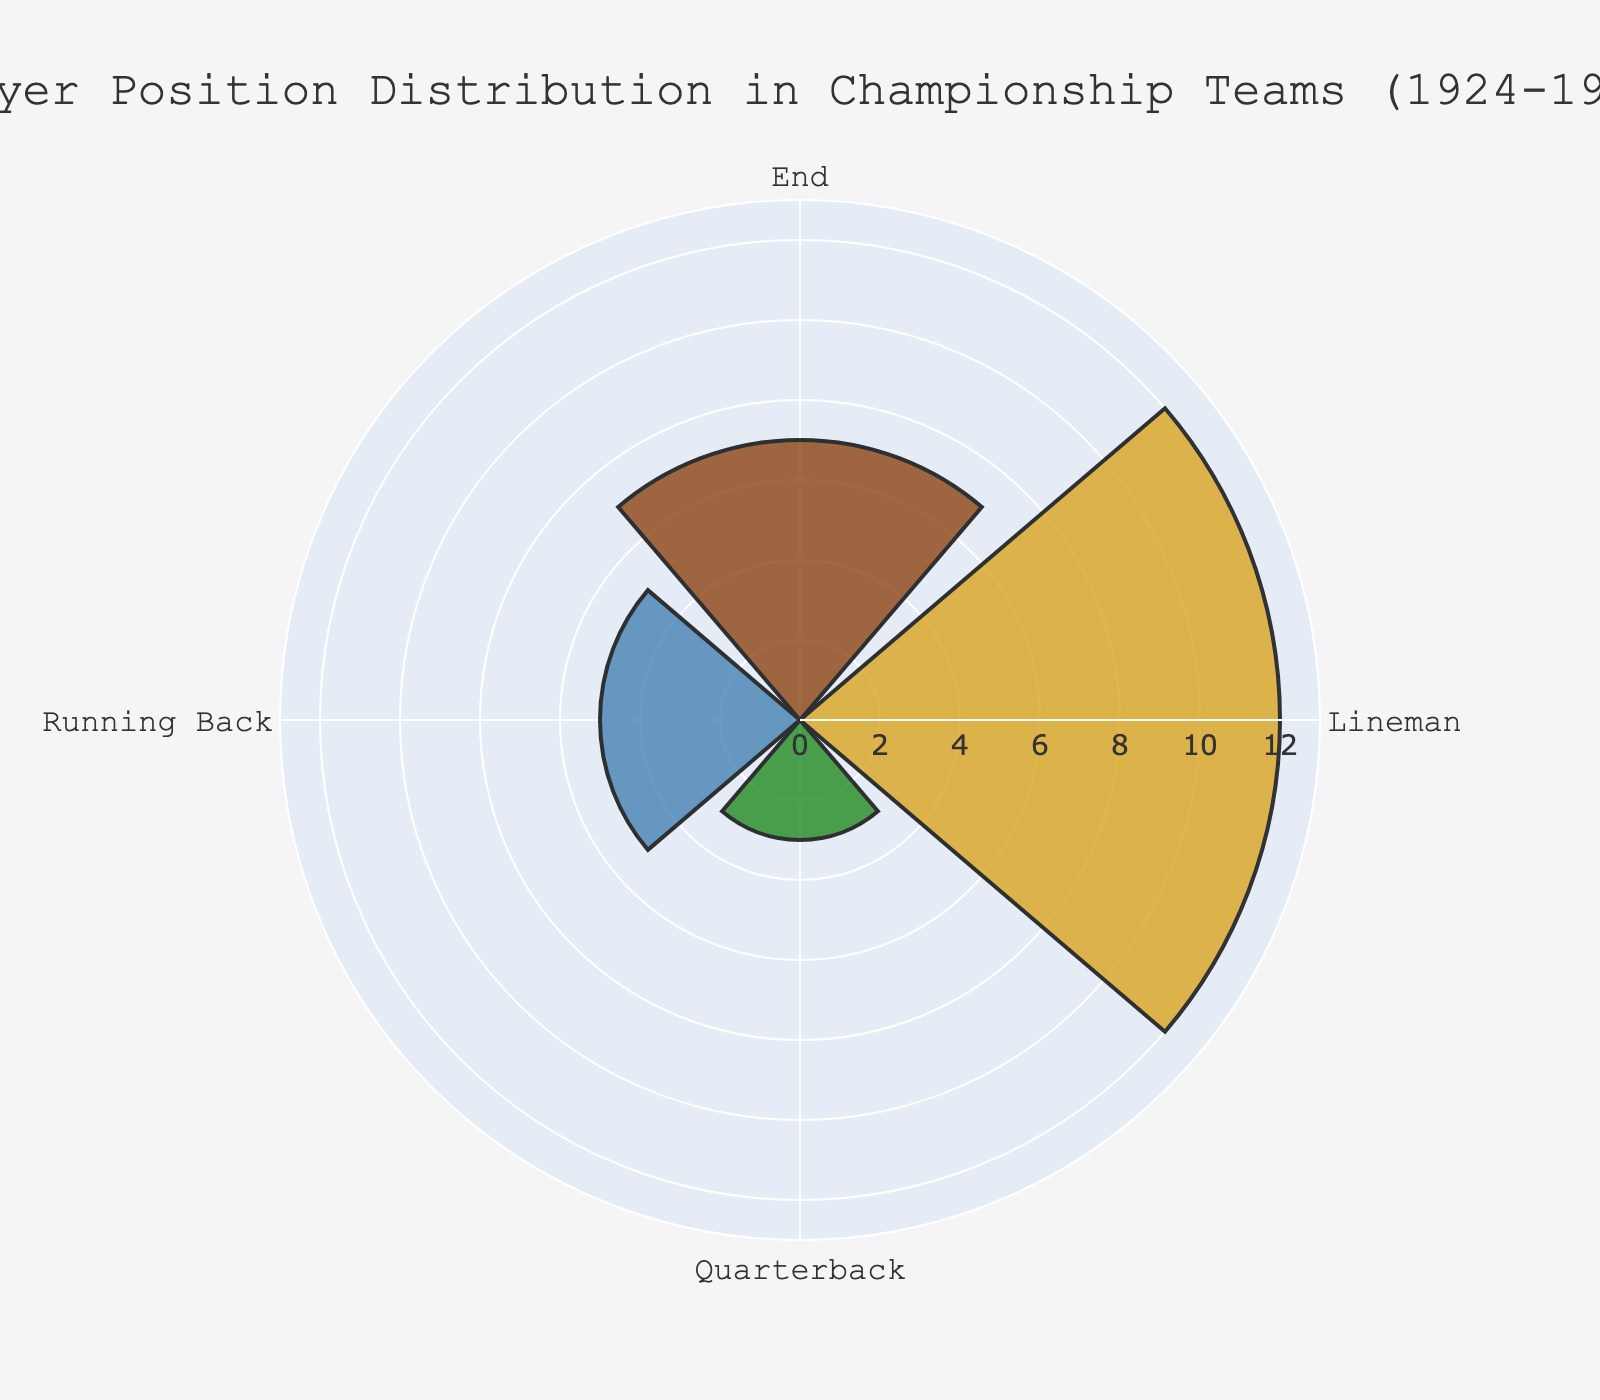what is the title of the figure? The title is prominently located at the top of the figure. It reads "Player Position Distribution in Championship Teams (1924-1926)".
Answer: Player Position Distribution in Championship Teams (1924-1926) How many different player positions are represented in the figure? The figure has sections marked for different player positions. By inspecting these sections, we can see there are four positions labeled: Quarterback, Running Back, Lineman, and End.
Answer: Four Which position has the highest count in the figure? We can determine this by looking at the length of the sections on the rose chart. The section with the greatest radial extent represents the Lineman position.
Answer: Lineman How many counts does the End position have? We need to look at the length of the section that corresponds to the End position. From the figure, it's marked at the radial value, and the hover text confirms it.
Answer: Seven What is the total count of all player positions combined? We sum up the counts for all positions: Quarterback (3), Running Back (5), Lineman (12), and End (7). These add to 3 + 5 + 12 + 7 = 27.
Answer: 27 How does the count of Running Backs compare to that of Quarterbacks? By looking at the lengths of the sections, the Running Backs have more counts than the Quarterbacks. The exact counts are 5 for Running Backs and 3 for Quarterbacks.
Answer: Running Backs > Quarterbacks What is the average count per player position? We sum up the counts for all positions to get a total of 27. There are four positions, so the average is 27 / 4 = 6.75.
Answer: 6.75 How many more Linemen are there than Quarterbacks? By comparing the counts for Lineman and Quarterback, we find Lineman has 12 and Quarterback has 3. The difference is 12 - 3 = 9.
Answer: 9 Which position has the fewest counts? By observing the shortest section, which represents Quarterback, we identify it as having the fewest counts.
Answer: Quarterback Which position appears between Quarterback and Lineman on the rose chart? By observing the positional order on the chart, we see that Running Back is located between Quarterback and Lineman.
Answer: Running Back 